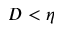<formula> <loc_0><loc_0><loc_500><loc_500>D < \eta</formula> 